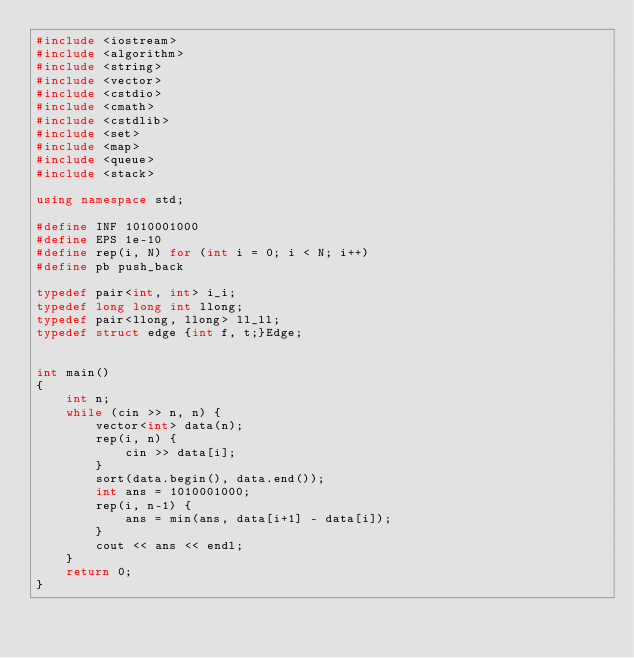Convert code to text. <code><loc_0><loc_0><loc_500><loc_500><_C++_>#include <iostream>
#include <algorithm>
#include <string>
#include <vector>
#include <cstdio>
#include <cmath>
#include <cstdlib>
#include <set>
#include <map>
#include <queue>
#include <stack>

using namespace std;

#define INF 1010001000
#define EPS 1e-10
#define rep(i, N) for (int i = 0; i < N; i++)
#define pb push_back

typedef pair<int, int> i_i;
typedef long long int llong;
typedef pair<llong, llong> ll_ll;
typedef struct edge {int f, t;}Edge;


int main()
{
    int n;
    while (cin >> n, n) {
        vector<int> data(n);
        rep(i, n) {
            cin >> data[i];
        }
        sort(data.begin(), data.end());
        int ans = 1010001000;
        rep(i, n-1) {
            ans = min(ans, data[i+1] - data[i]);
        }
        cout << ans << endl;
    }
    return 0;
}</code> 